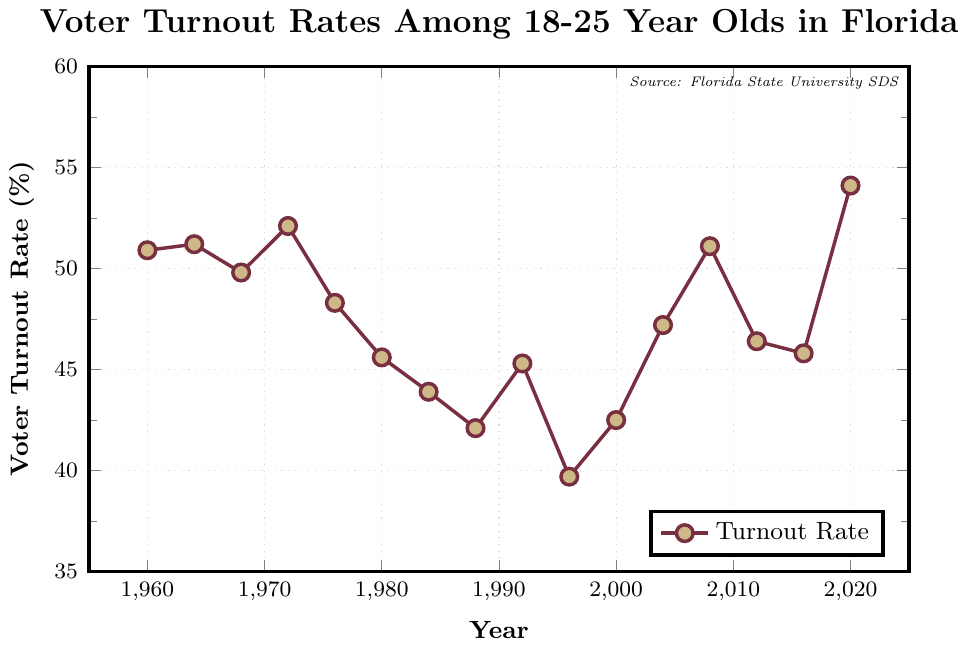What year had the highest voter turnout rate among 18-25 year olds in Florida? Locate the highest point on the line in the chart. The highest point corresponds to the year 2020.
Answer: 2020 What is the difference in voter turnout rate between 1984 and 2004? Find the voter turnout rates for 1984 and 2004, which are 43.9% and 47.2% respectively. The difference is 47.2% - 43.9% = 3.3%.
Answer: 3.3% During which periods did the voter turnout rate consistently decrease? Identify the intervals where the line consistently goes downward. This occurs from 1972 to 1988 and again from 2008 to 2012.
Answer: 1972-1988, 2008-2012 What is the average voter turnout rate from 1960 to 1980? Sum the voter turnout rates from 1960 to 1980: (50.9 + 51.2 + 49.8 + 52.1 + 48.3 + 45.6) = 298.9. Divide by the number of years, which is 6: 298.9 / 6 ≈ 49.82%.
Answer: 49.82% How does the voter turnout rate in 1996 compare to the rate in 2000? Check the voter turnout rates for 1996 and 2000, which are 39.7% and 42.5% respectively. The rate in 2000 is higher than in 1996.
Answer: Higher in 2000 Between which two consecutive presidential elections did the voter turnout rate increase the most? Calculate the differences between each consecutive data point and find the maximum: 
- 1960 to 1964: 51.2 - 50.9 = 0.3%
- 1964 to 1968: 49.8 - 51.2 = -1.4%
- 1968 to 1972: 52.1 - 49.8 = 2.3%
- 1972 to 1976: 48.3 - 52.1 = -3.8%
- 1976 to 1980: 45.6 - 48.3 = -2.7%
- 1980 to 1984: 43.9 - 45.6 = -1.7%
- 1984 to 1988: 42.1 - 43.9 = -1.8%
- 1988 to 1992: 45.3 - 42.1 = 3.2%
- 1992 to 1996: 39.7 - 45.3 = -5.6%
- 1996 to 2000: 42.5 - 39.7 = 2.8%
- 2000 to 2004: 47.2 - 42.5 = 4.7%
- 2004 to 2008: 51.1 - 47.2 = 3.9%
- 2008 to 2012: 46.4 - 51.1 = -4.7%
- 2012 to 2016: 45.8 - 46.4 = -0.6%
- 2016 to 2020: 54.1 - 45.8 = 8.3%
The maximum increase occurred between 2016 and 2020.
Answer: 2016 to 2020 What visual element indicates the source of the data in the chart? Look for any textual or annotated information in the chart. A note in the top right corner mentions "Source: Florida State University SDS".
Answer: Note in the top right corner Based on the chart, identify any years when the voter turnout rate among 18-25 year olds was below 40%. Locate the points on the line where the voter turnout rate is less than 40%. This happened in 1996.
Answer: 1996 